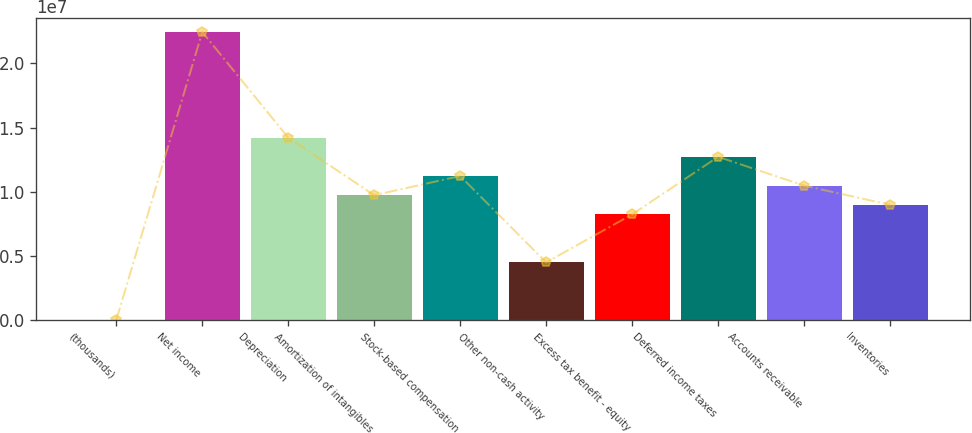Convert chart. <chart><loc_0><loc_0><loc_500><loc_500><bar_chart><fcel>(thousands)<fcel>Net income<fcel>Depreciation<fcel>Amortization of intangibles<fcel>Stock-based compensation<fcel>Other non-cash activity<fcel>Excess tax benefit - equity<fcel>Deferred income taxes<fcel>Accounts receivable<fcel>Inventories<nl><fcel>2014<fcel>2.24515e+07<fcel>1.422e+07<fcel>9.73011e+06<fcel>1.12267e+07<fcel>4.4919e+06<fcel>8.23348e+06<fcel>1.27234e+07<fcel>1.04784e+07<fcel>8.98179e+06<nl></chart> 